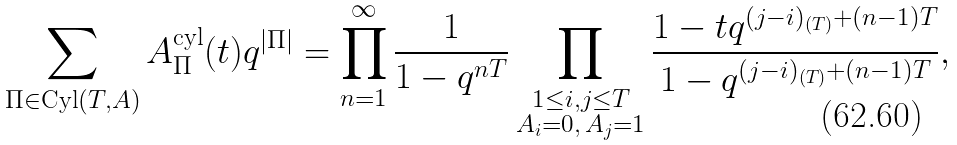Convert formula to latex. <formula><loc_0><loc_0><loc_500><loc_500>\sum _ { \Pi \in \text {Cyl} ( T , A ) } A ^ { \text {cyl} } _ { \Pi } ( t ) q ^ { | \Pi | } = \prod _ { n = 1 } ^ { \infty } \frac { 1 } { 1 - q ^ { n T } } \prod _ { \substack { 1 \leq i , j \leq T \\ A _ { i } = 0 , \, A _ { j } = 1 } } \frac { 1 - t q ^ { ( j - i ) _ { ( T ) } + ( n - 1 ) T } } { 1 - q ^ { ( j - i ) _ { ( T ) } + ( n - 1 ) T } } ,</formula> 